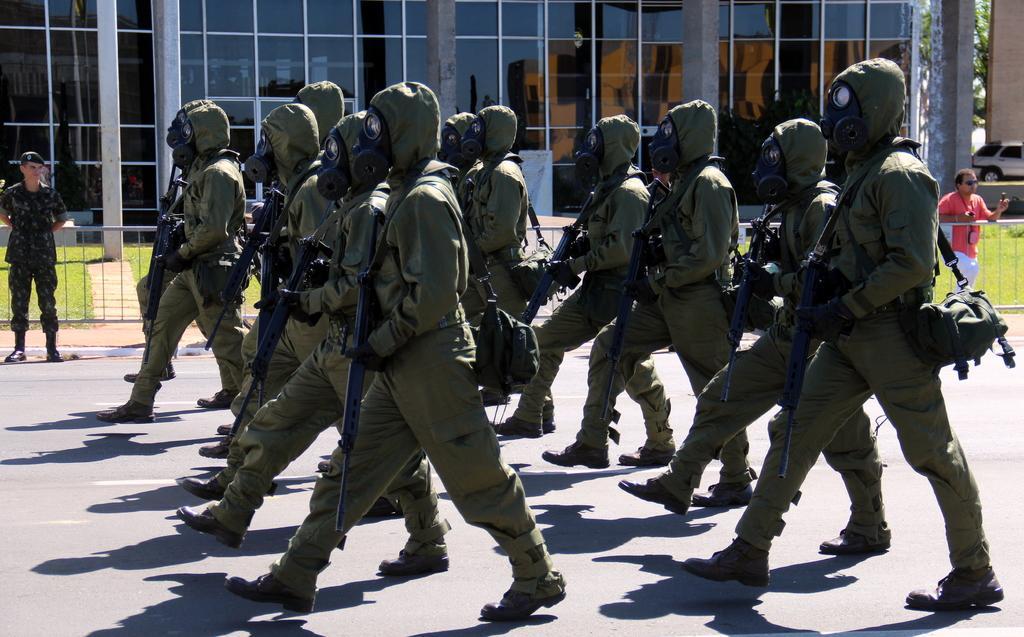In one or two sentences, can you explain what this image depicts? This image is taken outdoors. At the bottom of the image there is a road. In the background there is a building. There is a railing and there is a ground with grass on it. On the right side of the image a car is parked on the ground and there is a tree. A man is walking on the road. In the middle of the image a few people are walking on the road and they are holding guns in their hands. On the left side of the image a man is standing on the road. 